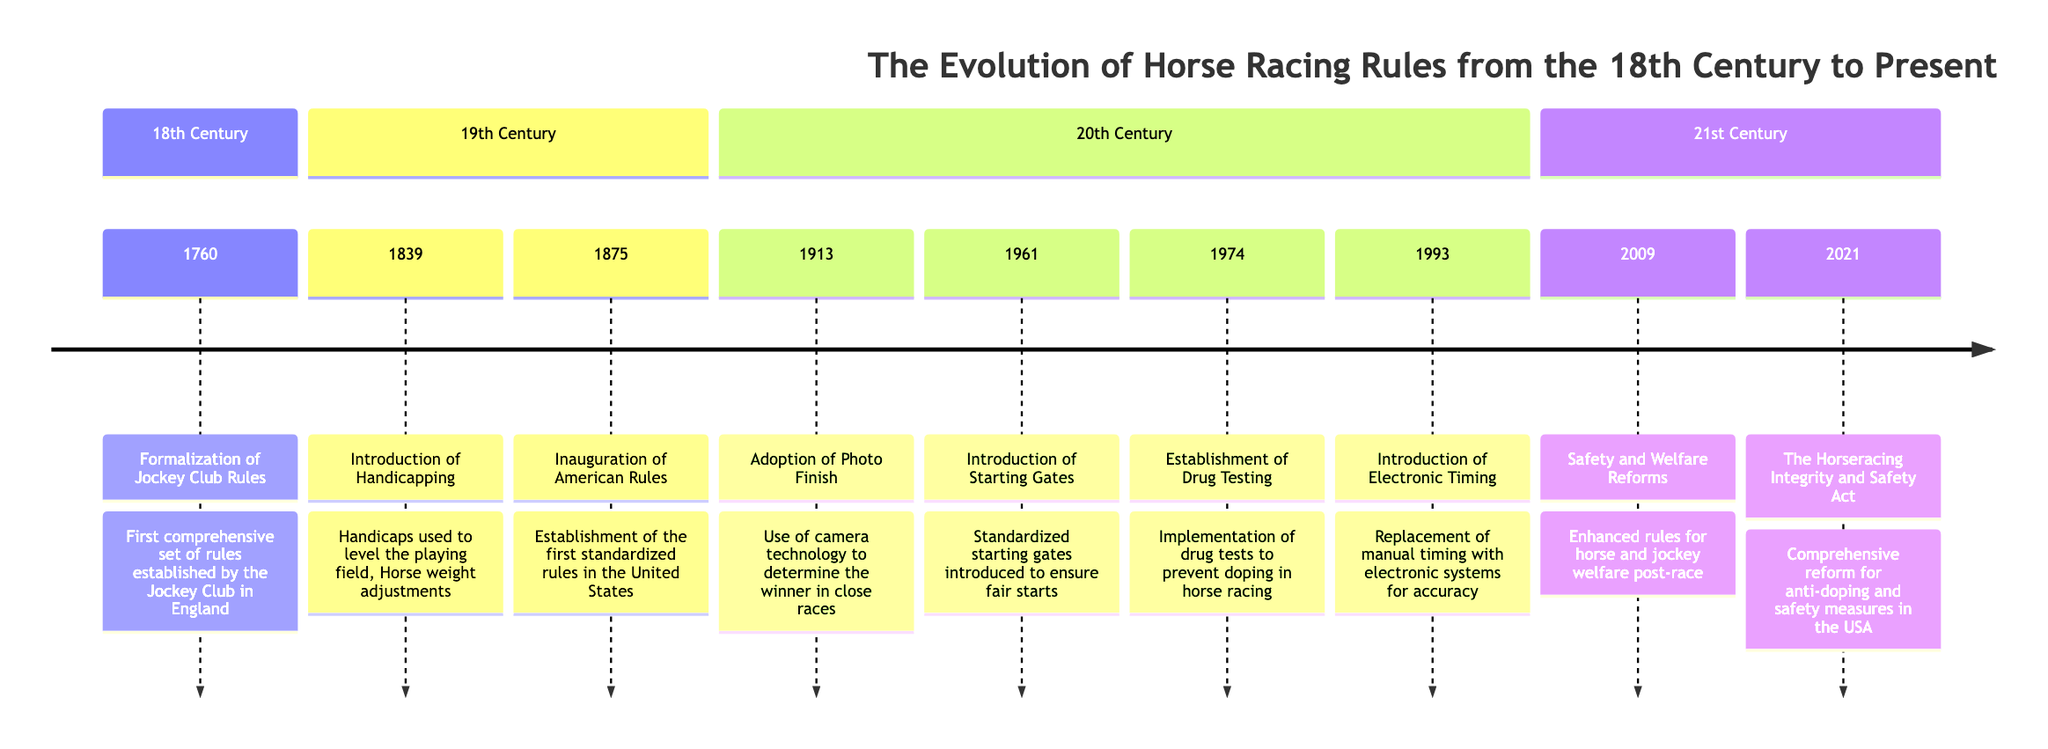What year did the Jockey Club first establish comprehensive rules? The diagram states that the formalization of Jockey Club Rules occurred in 1760 in the 18th Century section. Therefore, the answer is directly drawn from this specific mention.
Answer: 1760 What is the key development introduced in 1839? The diagram highlights the introduction of Handicapping in 1839. This detail indicates that handicaps were used to level the playing field in horse racing, making this a clear point of reference in the timeline.
Answer: Handicapping In which century were the American Rules inaugurated? Referring to the diagram, the inauguration of American Rules took place in 1875, which is positioned in the 19th Century section, hence indicating that this development falls within that century.
Answer: 19th Century How many major milestones are documented in the 20th Century? The timeline indicates four distinct milestones occurring in the 20th Century; these are the Adoption of Photo Finish, Introduction of Starting Gates, Establishment of Drug Testing, and Introduction of Electronic Timing. Counting these tells us the total number of documented milestones.
Answer: 4 What significant act was introduced in 2021? The diagram specifically notes the passing of The Horseracing Integrity and Safety Act in 2021 within the 21st Century section. This title directly answers the query regarding this particular year’s milestone.
Answer: The Horseracing Integrity and Safety Act Which technological advancement was adopted in 1913? The diagram indicates that the Adoption of Photo Finish occurred in 1913, showcasing a technological advancement meant to improve the accuracy of determining race winners.
Answer: Photo Finish What reform was established in 2009 regarding horse welfare? According to the diagram, the year 2009 saw the implementation of Safety and Welfare Reforms, reflecting a significant shift towards better post-race rules for both horses and jockeys.
Answer: Safety and Welfare Reforms Which milestone signifies the use of cameras in races? The timeline mentions Adoption of Photo Finish in 1913, marking this milestone as the introduction of camera technology for closely contested races, which is the specific detail sought by this question.
Answer: Adoption of Photo Finish What was a major introduction to enhance race starts in 1961? The diagram highlights the Introduction of Starting Gates as a significant improvement in 1961 to ensure fair starts in races, providing clarity and structure to racing events.
Answer: Starting Gates 